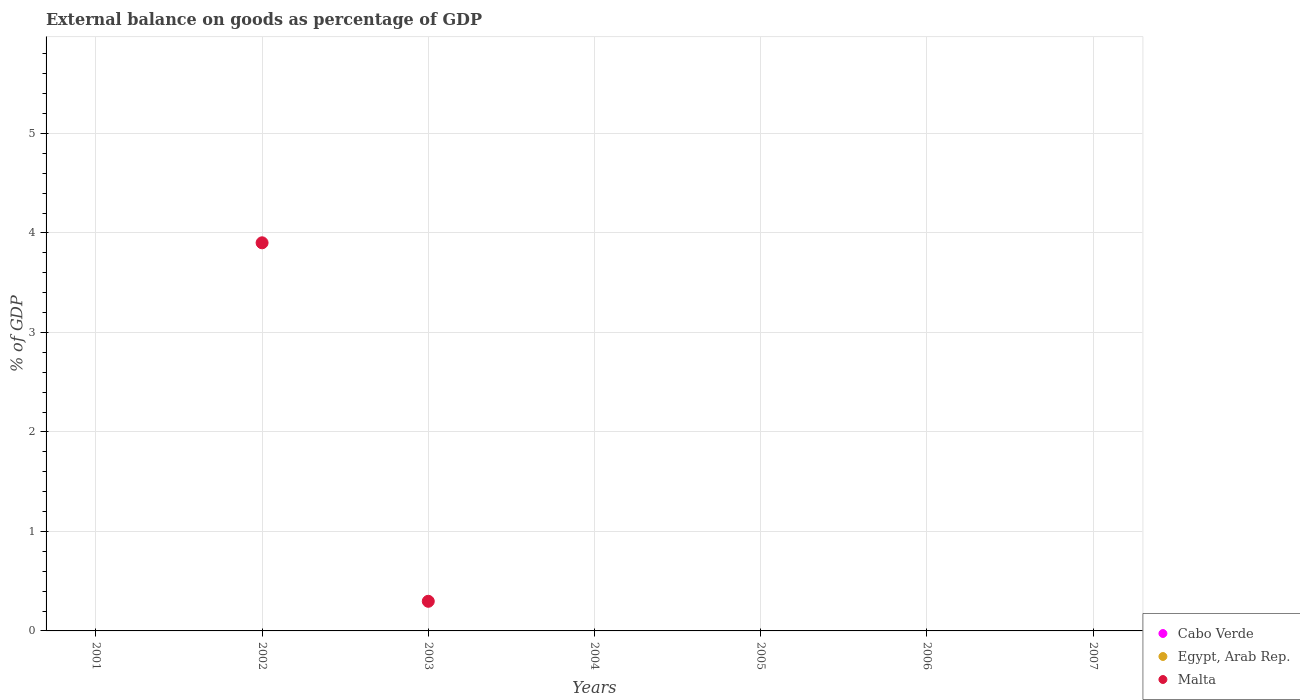How many different coloured dotlines are there?
Make the answer very short. 1. Across all years, what is the maximum external balance on goods as percentage of GDP in Malta?
Offer a very short reply. 3.9. Across all years, what is the minimum external balance on goods as percentage of GDP in Cabo Verde?
Provide a succinct answer. 0. What is the difference between the highest and the lowest external balance on goods as percentage of GDP in Malta?
Offer a very short reply. 3.9. Is it the case that in every year, the sum of the external balance on goods as percentage of GDP in Cabo Verde and external balance on goods as percentage of GDP in Malta  is greater than the external balance on goods as percentage of GDP in Egypt, Arab Rep.?
Provide a short and direct response. No. Does the external balance on goods as percentage of GDP in Malta monotonically increase over the years?
Provide a succinct answer. No. Is the external balance on goods as percentage of GDP in Cabo Verde strictly greater than the external balance on goods as percentage of GDP in Egypt, Arab Rep. over the years?
Your answer should be compact. No. Does the graph contain any zero values?
Provide a short and direct response. Yes. Does the graph contain grids?
Provide a short and direct response. Yes. Where does the legend appear in the graph?
Offer a terse response. Bottom right. How are the legend labels stacked?
Your response must be concise. Vertical. What is the title of the graph?
Give a very brief answer. External balance on goods as percentage of GDP. What is the label or title of the Y-axis?
Offer a very short reply. % of GDP. What is the % of GDP in Egypt, Arab Rep. in 2001?
Offer a terse response. 0. What is the % of GDP in Malta in 2001?
Your answer should be compact. 0. What is the % of GDP in Egypt, Arab Rep. in 2002?
Give a very brief answer. 0. What is the % of GDP of Malta in 2002?
Provide a succinct answer. 3.9. What is the % of GDP of Egypt, Arab Rep. in 2003?
Your answer should be compact. 0. What is the % of GDP in Malta in 2003?
Offer a terse response. 0.3. What is the % of GDP of Malta in 2004?
Your answer should be very brief. 0. What is the % of GDP of Egypt, Arab Rep. in 2005?
Your answer should be very brief. 0. What is the % of GDP in Malta in 2005?
Offer a terse response. 0. What is the % of GDP of Cabo Verde in 2006?
Make the answer very short. 0. What is the % of GDP of Egypt, Arab Rep. in 2006?
Provide a short and direct response. 0. What is the % of GDP of Cabo Verde in 2007?
Offer a terse response. 0. What is the % of GDP in Egypt, Arab Rep. in 2007?
Offer a terse response. 0. Across all years, what is the maximum % of GDP of Malta?
Offer a very short reply. 3.9. Across all years, what is the minimum % of GDP in Malta?
Offer a very short reply. 0. What is the total % of GDP of Cabo Verde in the graph?
Your response must be concise. 0. What is the total % of GDP of Malta in the graph?
Give a very brief answer. 4.2. What is the difference between the % of GDP in Malta in 2002 and that in 2003?
Keep it short and to the point. 3.6. What is the average % of GDP of Egypt, Arab Rep. per year?
Keep it short and to the point. 0. What is the average % of GDP of Malta per year?
Offer a terse response. 0.6. What is the ratio of the % of GDP of Malta in 2002 to that in 2003?
Your response must be concise. 13.1. What is the difference between the highest and the lowest % of GDP of Malta?
Provide a succinct answer. 3.9. 